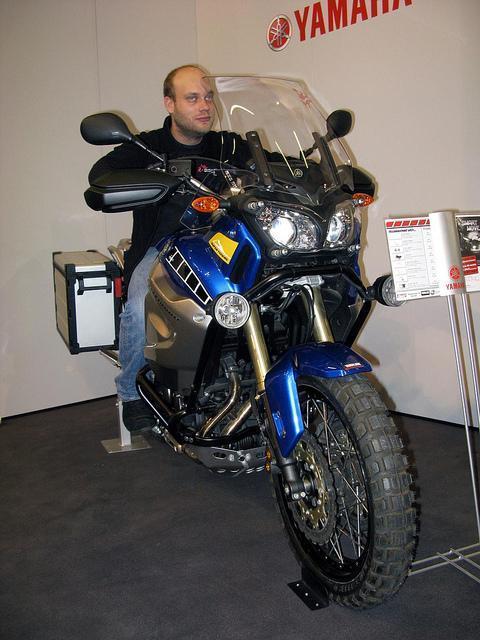How many people are in the picture?
Give a very brief answer. 2. How many scissors are in blue color?
Give a very brief answer. 0. 